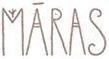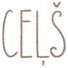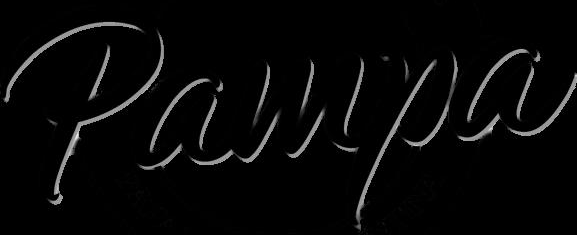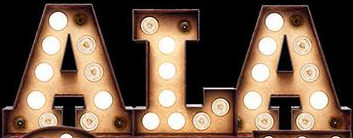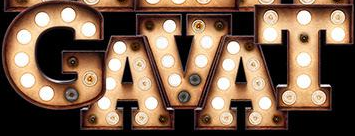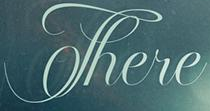Transcribe the words shown in these images in order, separated by a semicolon. MĀRAS; CEḶŠ; Pampa; ALA; GAVAT; There 